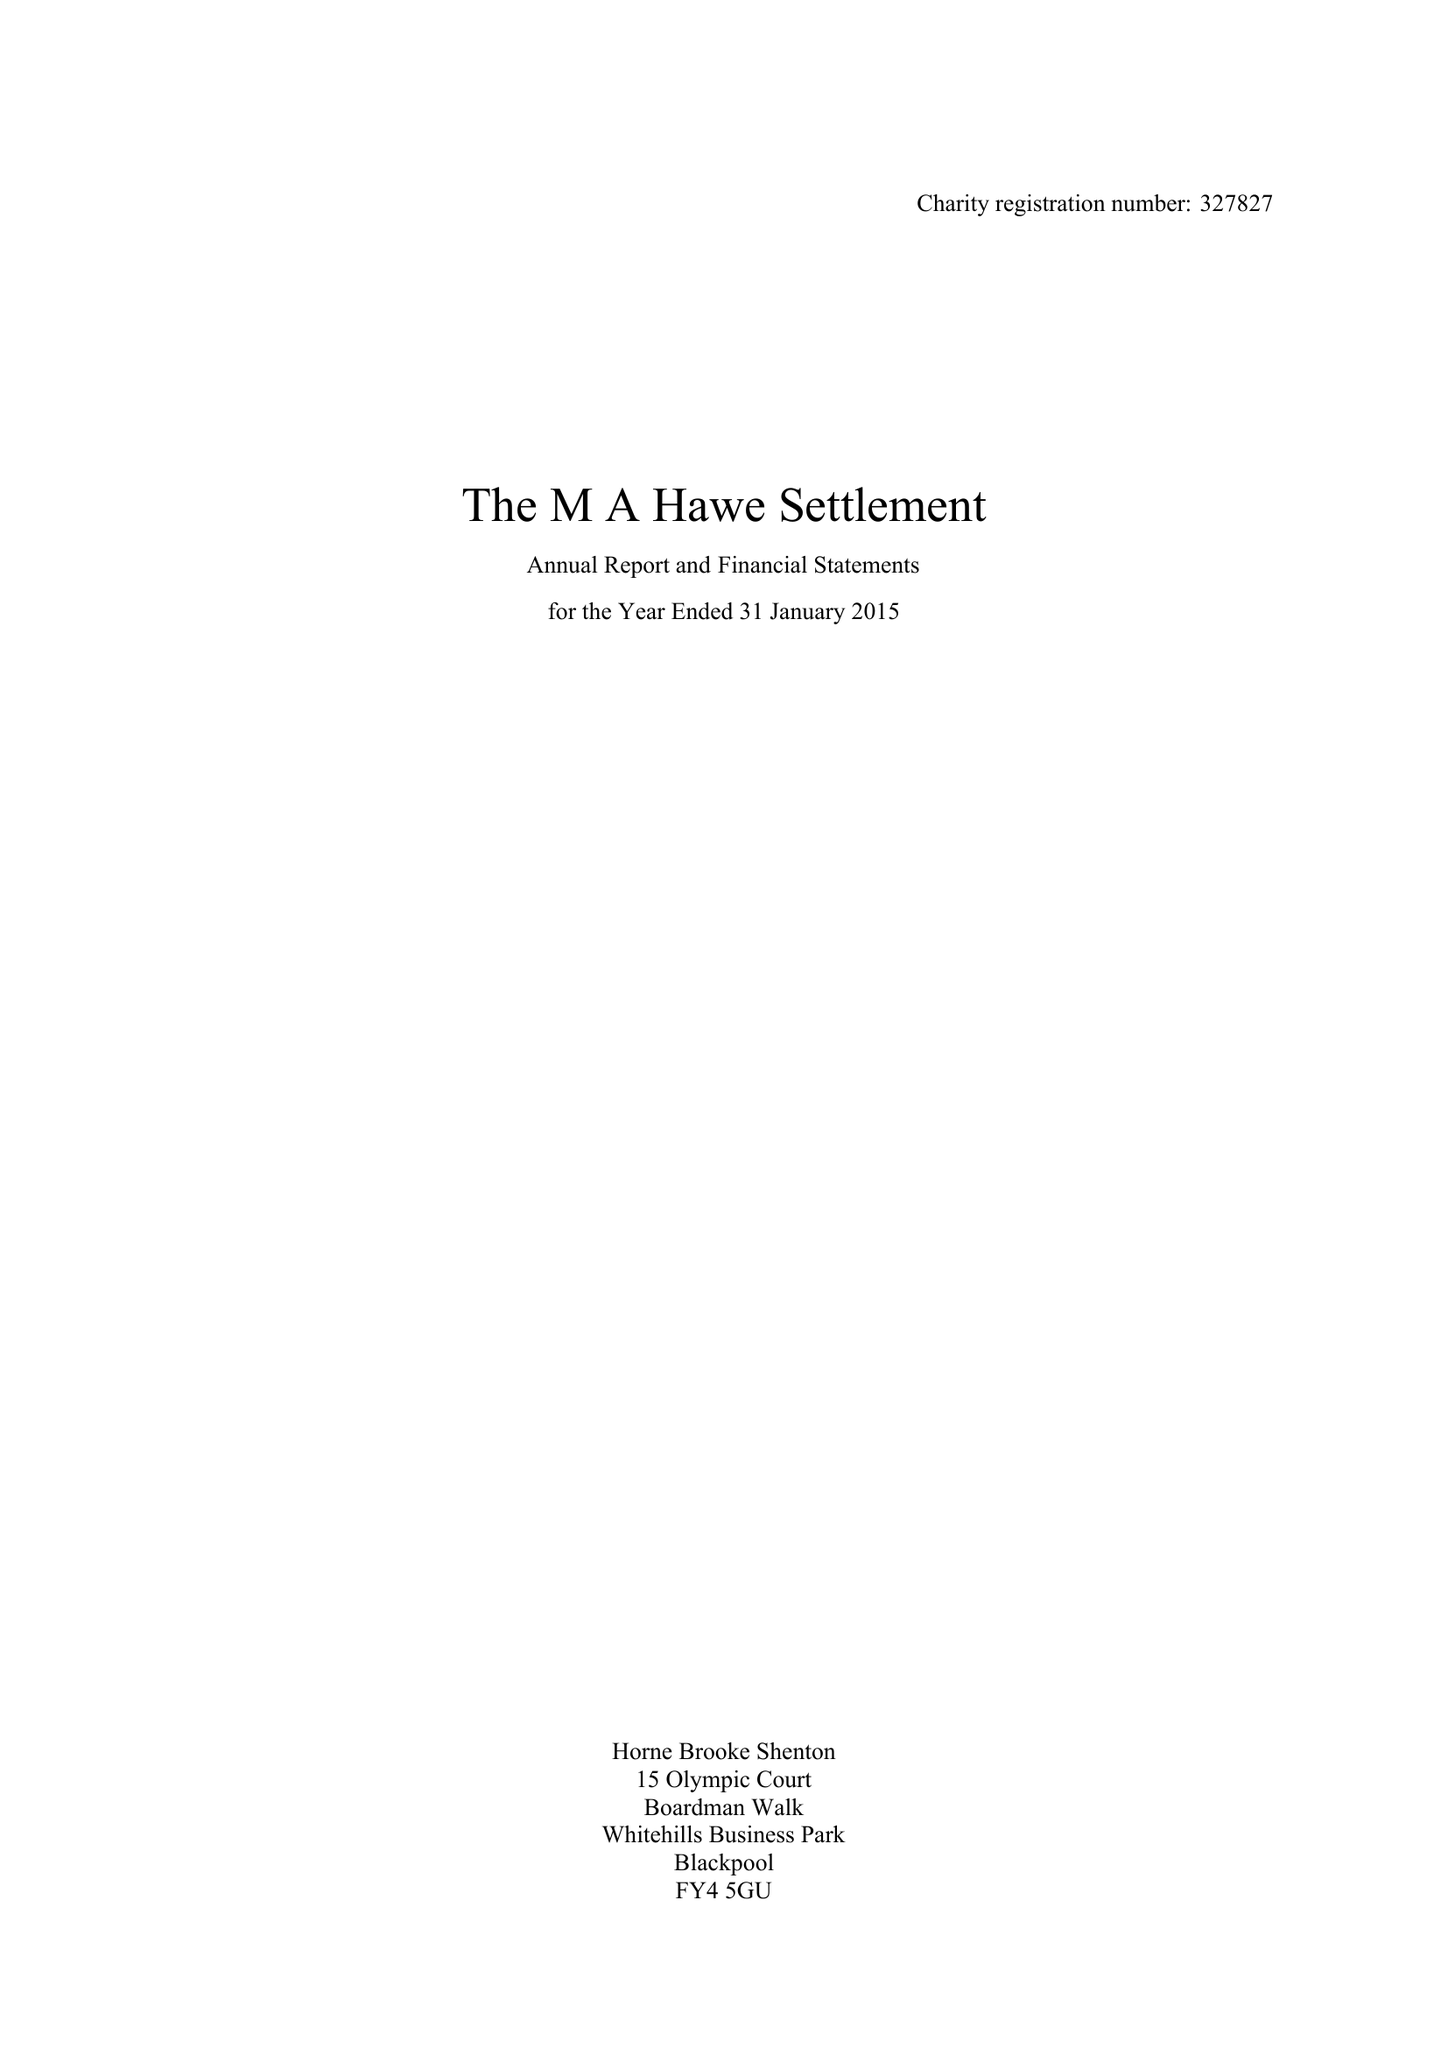What is the value for the address__post_town?
Answer the question using a single word or phrase. LYTHAM ST. ANNES 